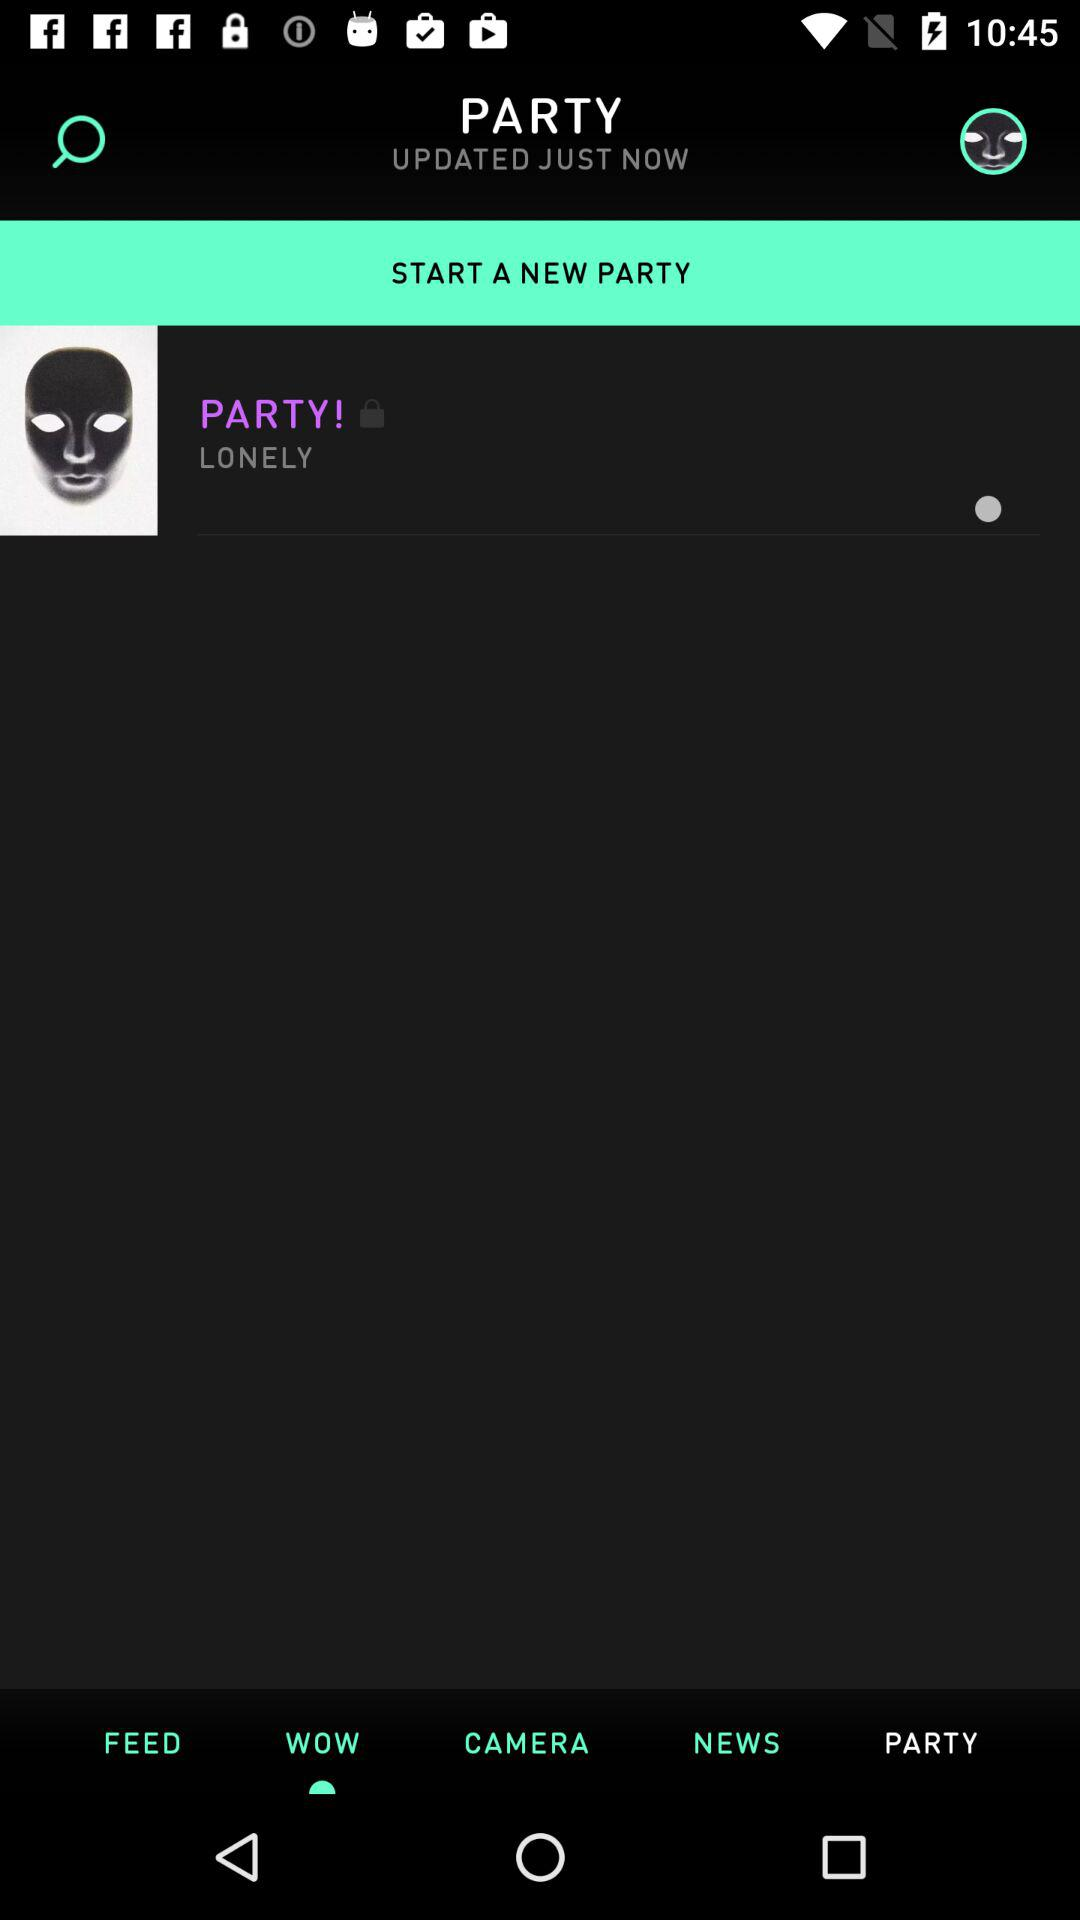When is the new party scheduled to begin?
When the provided information is insufficient, respond with <no answer>. <no answer> 